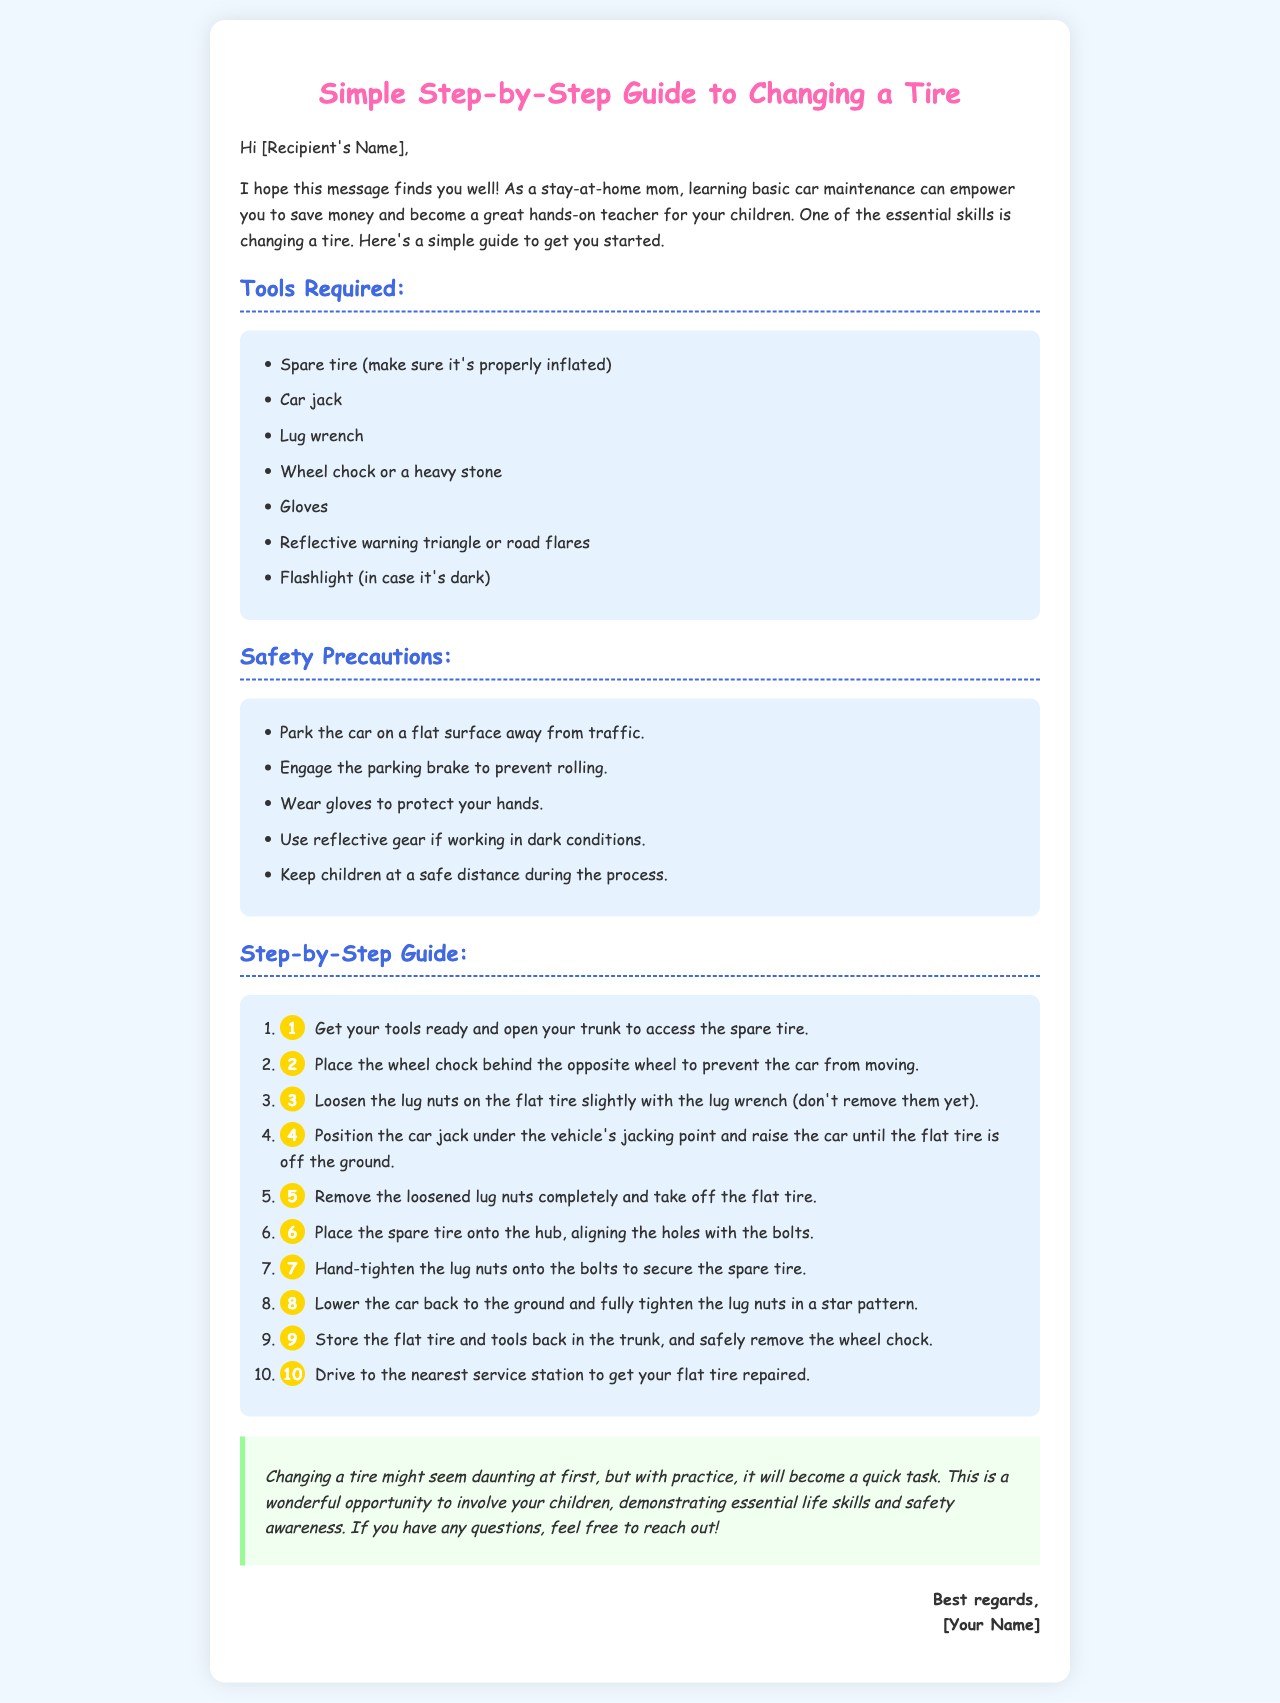What is the first tool listed required for changing a tire? The first tool mentioned in the document for changing a tire is a spare tire.
Answer: Spare tire How many steps are there in the tire changing process? The document outlines a total of ten steps for changing a tire.
Answer: 10 What should you use to prevent the car from moving? The document advises using a wheel chock or a heavy stone to prevent the car from rolling.
Answer: Wheel chock What color is the title of the guide? The color of the title "Simple Step-by-Step Guide to Changing a Tire" is pink.
Answer: Pink What should you wear for hand protection? The document recommends wearing gloves to protect your hands while changing a tire.
Answer: Gloves Which items should be kept at a safe distance during the process? The document states that children should be kept at a safe distance during the tire-changing process.
Answer: Children What is the purpose of the reflective warning triangle? The reflective warning triangle is used for safety if working in dark conditions or near traffic.
Answer: Safety What position should the car be in? The document specifies that the car should be parked on a flat surface away from traffic.
Answer: Flat surface What should you do after changing the tire? The document suggests driving to the nearest service station to get your flat tire repaired after changing it.
Answer: Nearest service station 